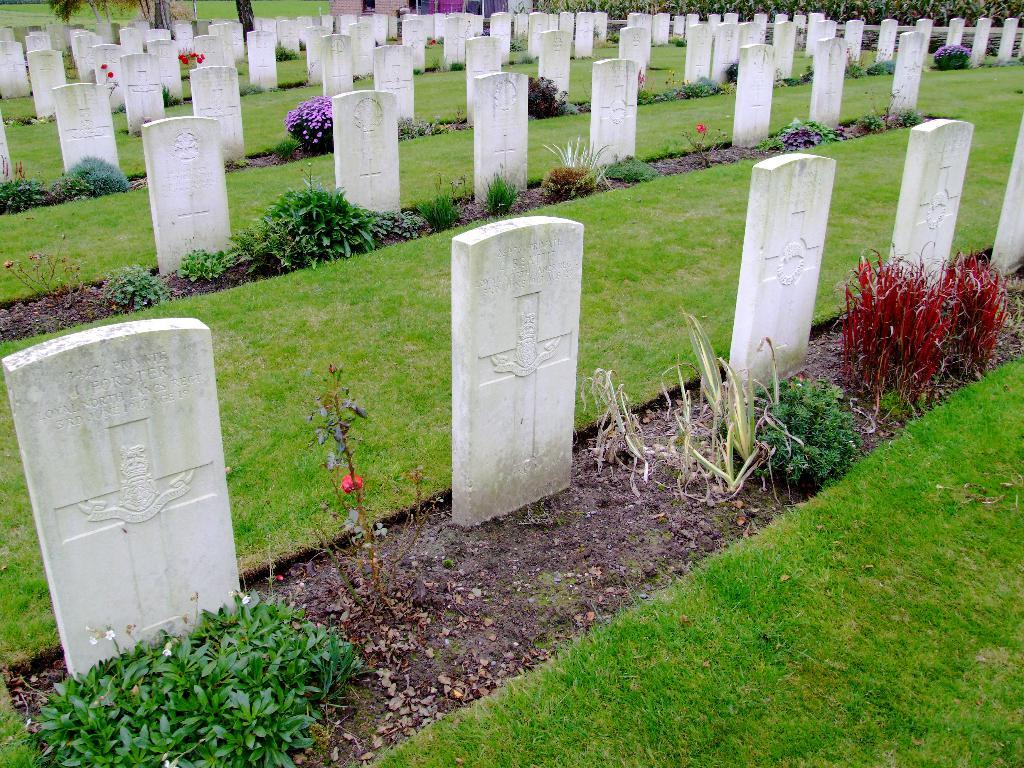What type of location is depicted in the image? There is a graveyard in the image. What type of vegetation can be seen in the image? There are plants with flowers in the image. What covers the ground in the image? Grass is present on the ground in the image. What can be seen at the top of the image? There are plants and other objects at the top of the image. What type of train can be seen passing through the graveyard in the image? There is no train present in the image; it is a graveyard with plants, flowers, and grass. 